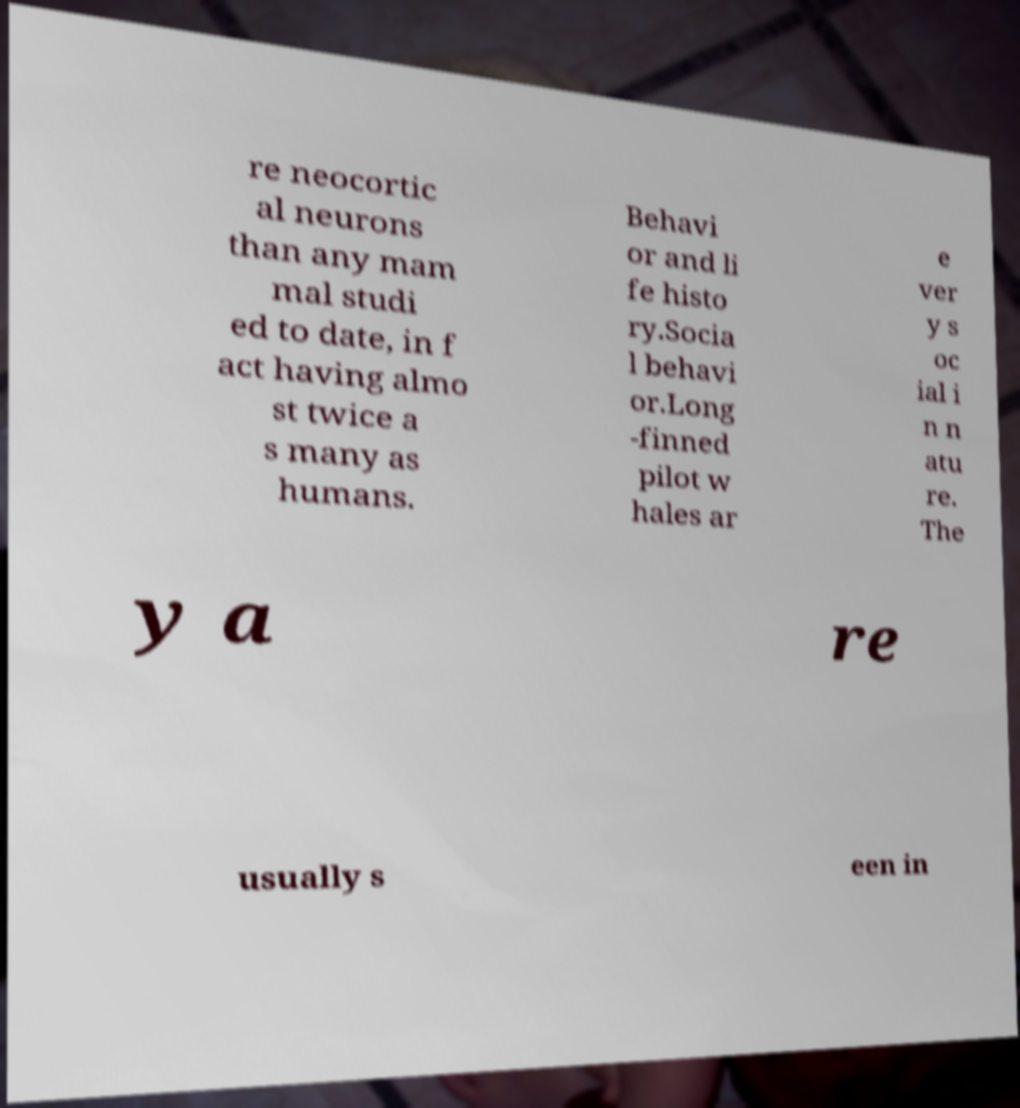Please identify and transcribe the text found in this image. re neocortic al neurons than any mam mal studi ed to date, in f act having almo st twice a s many as humans. Behavi or and li fe histo ry.Socia l behavi or.Long -finned pilot w hales ar e ver y s oc ial i n n atu re. The y a re usually s een in 